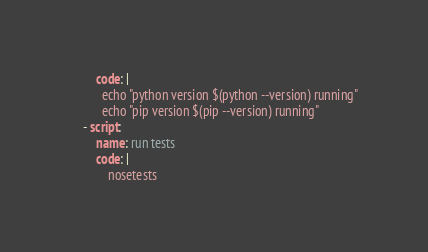<code> <loc_0><loc_0><loc_500><loc_500><_YAML_>        code: |
          echo "python version $(python --version) running"
          echo "pip version $(pip --version) running"
    - script:
        name: run tests
        code: |
            nosetests</code> 